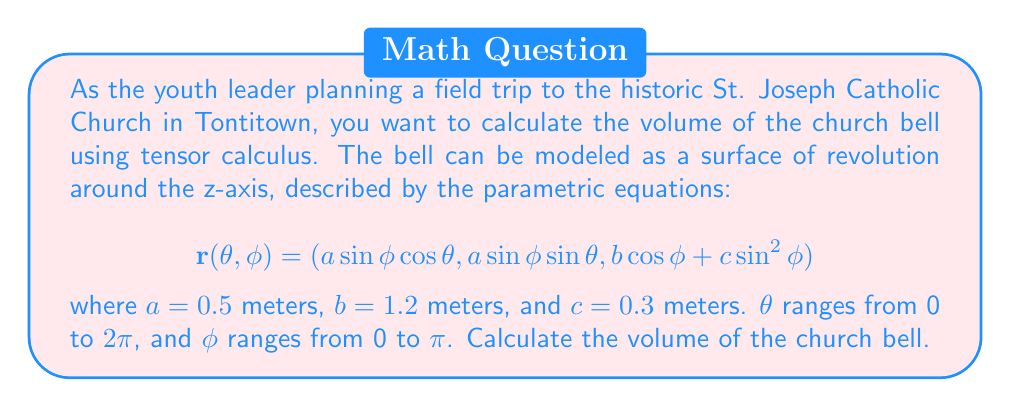Could you help me with this problem? To calculate the volume of the church bell using tensor calculus, we'll follow these steps:

1) First, we need to calculate the metric tensor $g_{ij}$. The components are given by:

   $$g_{ij} = \frac{\partial r}{\partial u^i} \cdot \frac{\partial r}{\partial u^j}$$

   where $u^1 = \theta$ and $u^2 = \phi$.

2) Calculate the partial derivatives:

   $$\frac{\partial r}{\partial \theta} = (-a\sin\phi\sin\theta, a\sin\phi\cos\theta, 0)$$
   $$\frac{\partial r}{\partial \phi} = (a\cos\phi\cos\theta, a\cos\phi\sin\theta, -b\sin\phi + 2c\sin\phi\cos\phi)$$

3) Now, calculate the components of the metric tensor:

   $$g_{11} = a^2\sin^2\phi$$
   $$g_{12} = g_{21} = 0$$
   $$g_{22} = a^2\cos^2\phi + (-b\sin\phi + 2c\sin\phi\cos\phi)^2$$

4) The determinant of the metric tensor is:

   $$\det(g_{ij}) = g_{11}g_{22} = a^2\sin^2\phi[a^2\cos^2\phi + (-b\sin\phi + 2c\sin\phi\cos\phi)^2]$$

5) The volume is given by the integral:

   $$V = \int_0^{2\pi}\int_0^{\pi}\sqrt{\det(g_{ij})}d\phi d\theta$$

6) Substituting the values:

   $$V = \int_0^{2\pi}\int_0^{\pi}0.5\sin\phi\sqrt{0.25\cos^2\phi + (-1.2\sin\phi + 0.6\sin\phi\cos\phi)^2}d\phi d\theta$$

7) This integral cannot be solved analytically, so we need to use numerical integration. Using a computational tool, we find:

   $$V \approx 1.0472 \text{ cubic meters}$$
Answer: $1.0472 \text{ m}^3$ 